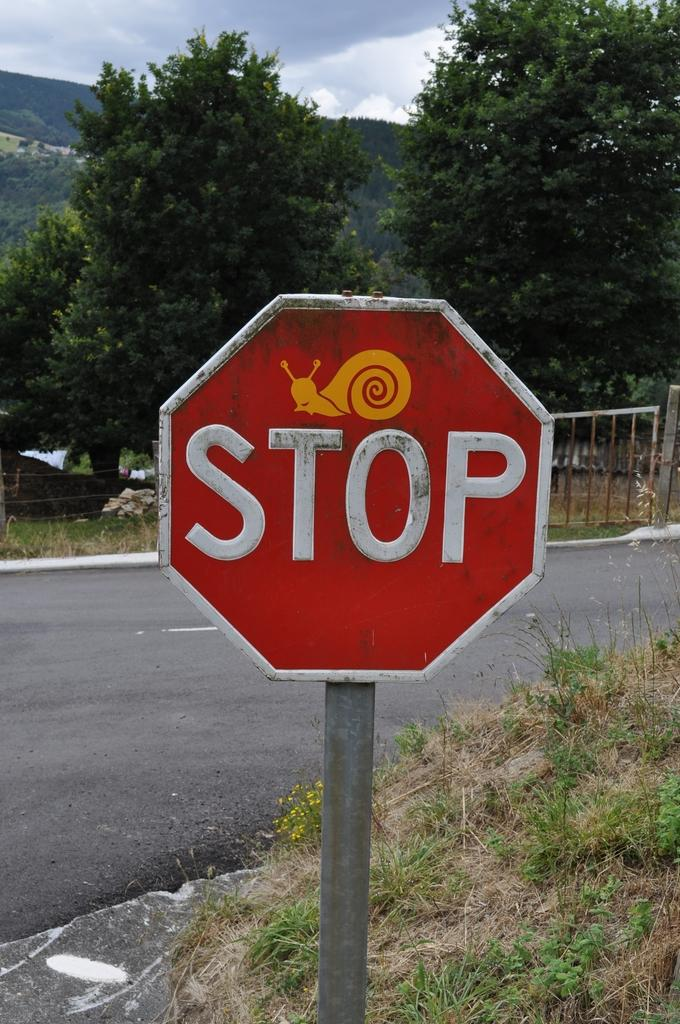<image>
Describe the image concisely. Red Stop sign with a picture of a snail on it. 